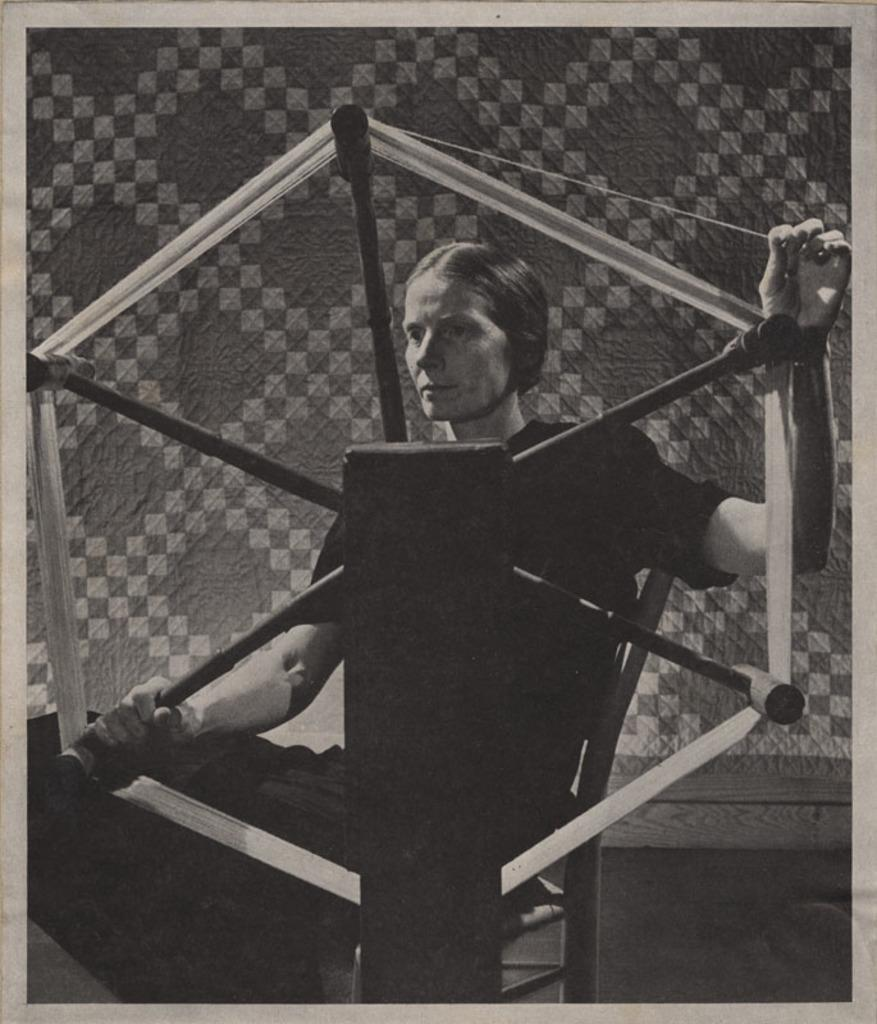Who is present in the image? There is a woman in the image. What is the woman holding in her hand? The woman is holding a wheel in her hand. What can be seen in the background of the image? There is a wall in the background of the image. Where is the machine that the cows are using in the image? There is no machine or cows present in the image. 